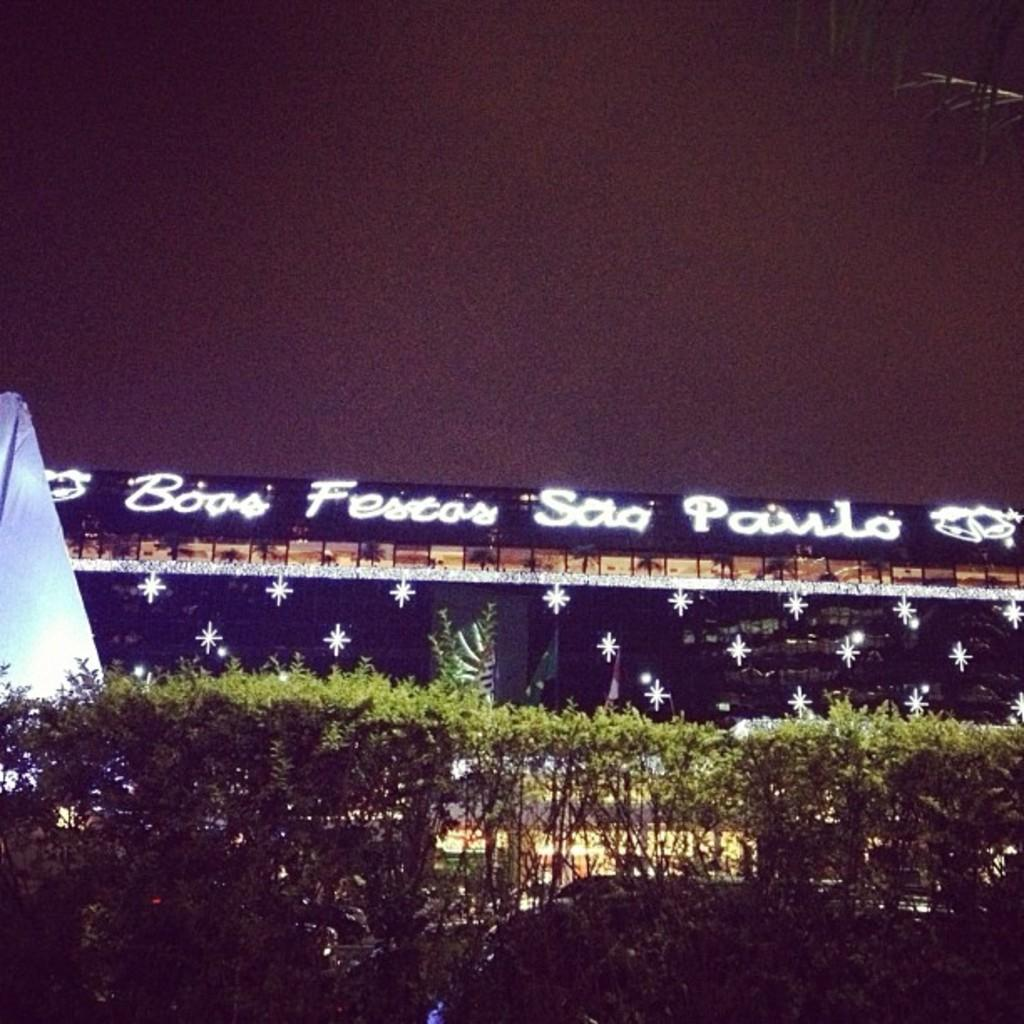What type of vegetation is at the bottom of the image? There are bushes at the bottom of the image. What structure is located in the center of the image? There is a shed in the center of the image. What is visible at the top of the image? The sky is visible at the top of the image. Can you see a stream flowing through the shed in the image? There is no stream visible in the image; it only features bushes, a shed, and the sky. How many hands are visible holding the shed in the image? There are no hands visible in the image, as the shed appears to be standing on its own. 